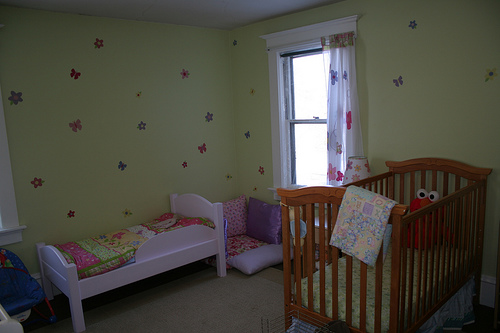<image>
Is the towel on the cradle? Yes. Looking at the image, I can see the towel is positioned on top of the cradle, with the cradle providing support. Is there a pillow on the bed? No. The pillow is not positioned on the bed. They may be near each other, but the pillow is not supported by or resting on top of the bed. Is the curtain on the window? No. The curtain is not positioned on the window. They may be near each other, but the curtain is not supported by or resting on top of the window. 